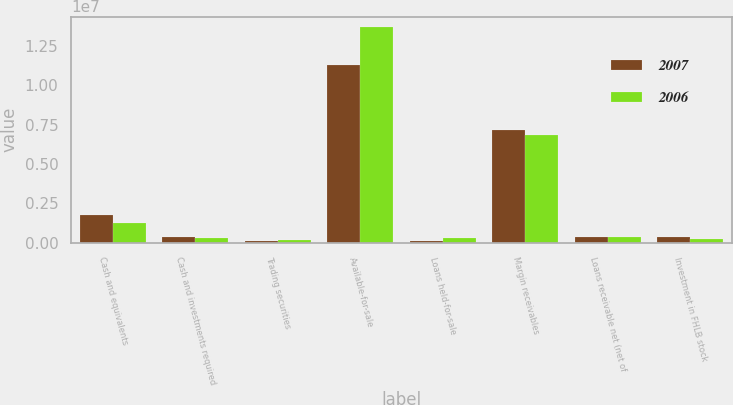<chart> <loc_0><loc_0><loc_500><loc_500><stacked_bar_chart><ecel><fcel>Cash and equivalents<fcel>Cash and investments required<fcel>Trading securities<fcel>Available-for-sale<fcel>Loans held-for-sale<fcel>Margin receivables<fcel>Loans receivable net (net of<fcel>Investment in FHLB stock<nl><fcel>2007<fcel>1.77824e+06<fcel>334831<fcel>130018<fcel>1.1255e+07<fcel>100539<fcel>7.17918e+06<fcel>336708<fcel>338585<nl><fcel>2006<fcel>1.21223e+06<fcel>281622<fcel>178600<fcel>1.36778e+07<fcel>283496<fcel>6.82845e+06<fcel>336708<fcel>244212<nl></chart> 